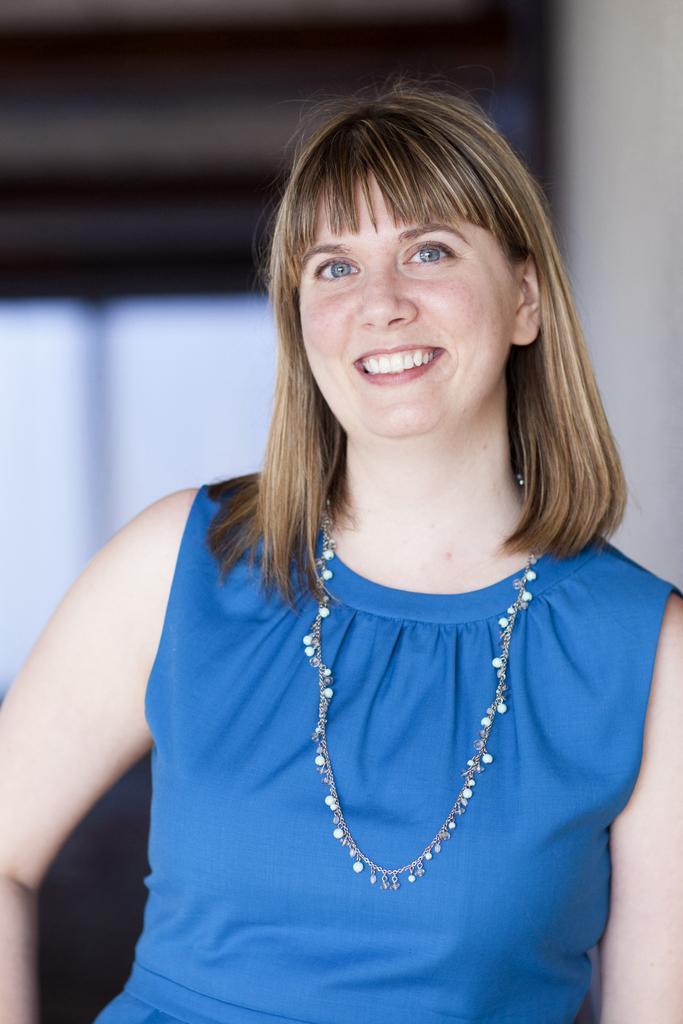Please provide a concise description of this image. In the image we can see a woman wearing blue color dress, neck chain and the woman is smiling, and the background is blurred. 